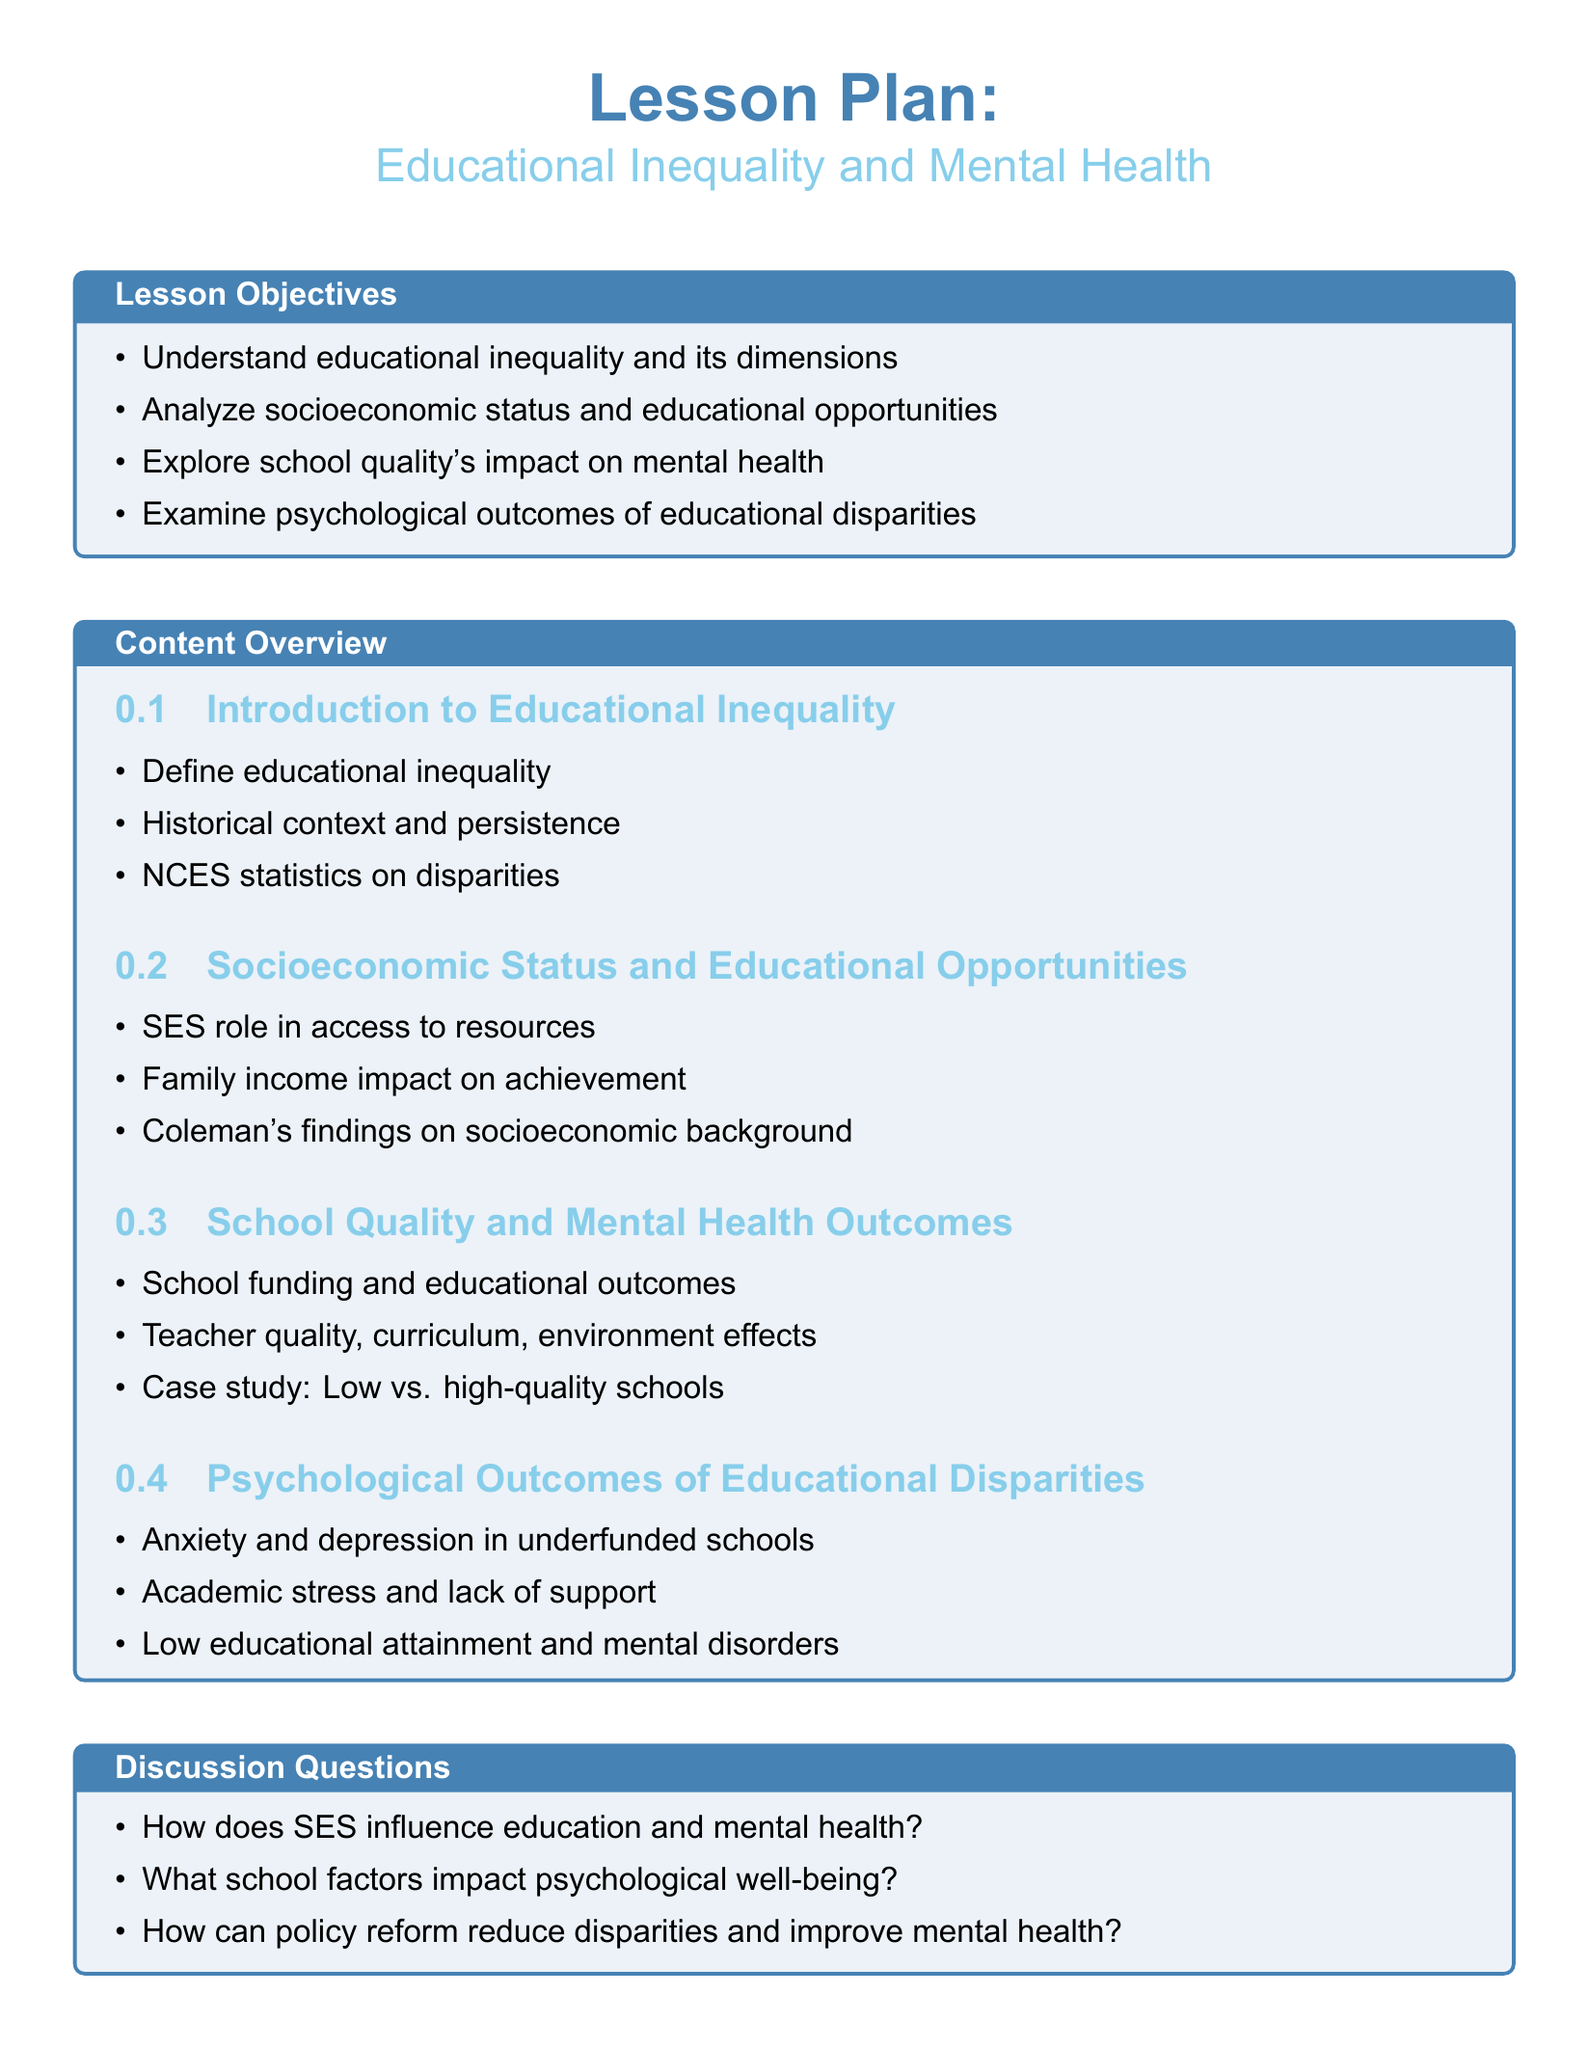What is the main topic of the lesson plan? The main topic of the lesson plan is "Educational Inequality and Mental Health."
Answer: Educational Inequality and Mental Health How many lesson objectives are listed? The document explicitly lists four lesson objectives.
Answer: 4 What does SES stand for? SES is defined in the document as Socioeconomic Status.
Answer: Socioeconomic Status Which report is referenced related to socioeconomic background? The document mentions the "Coleman Report" in connection to socioeconomic background.
Answer: Coleman Report What type of activity involves personal experiences? The document lists "Group discussion on personal experiences" as one of the activities.
Answer: Group discussion on personal experiences What psychological outcome is mentioned in underfunded schools? The document states "Anxiety and depression" as psychological outcomes in underfunded schools.
Answer: Anxiety and depression What kind of case study is included in the lesson plan? The lesson plan includes a case study comparing "mental health in different schools."
Answer: Compare mental health in different schools What colors are used for the title and subtitle? The title is in "maincolor" and the subtitle in "secondcolor."
Answer: maincolor and secondcolor What is one potential outcome of low educational attainment mentioned? The document states that "mental disorders" can be an outcome of low educational attainment.
Answer: mental disorders 